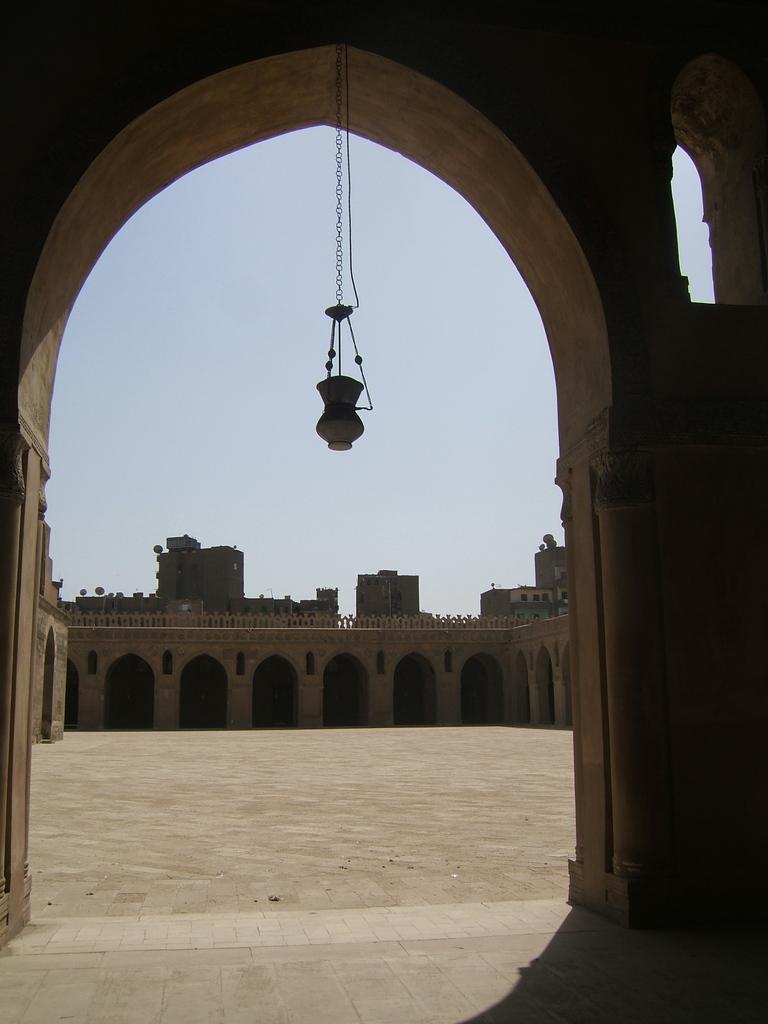How would you summarize this image in a sentence or two? In this picture there is an object hanging and we can see an ancient architecture and ground. In the background of the image we can see buildings and sky. 